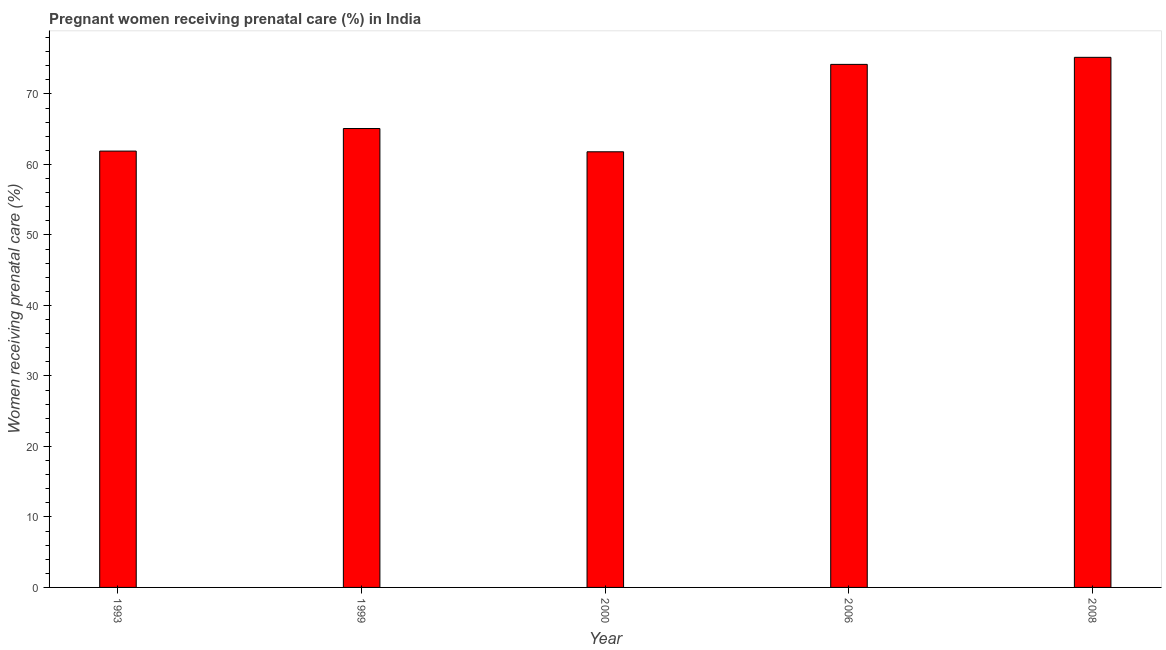Does the graph contain any zero values?
Your response must be concise. No. Does the graph contain grids?
Offer a very short reply. No. What is the title of the graph?
Offer a very short reply. Pregnant women receiving prenatal care (%) in India. What is the label or title of the Y-axis?
Your answer should be very brief. Women receiving prenatal care (%). What is the percentage of pregnant women receiving prenatal care in 1993?
Give a very brief answer. 61.9. Across all years, what is the maximum percentage of pregnant women receiving prenatal care?
Your answer should be very brief. 75.2. Across all years, what is the minimum percentage of pregnant women receiving prenatal care?
Keep it short and to the point. 61.8. In which year was the percentage of pregnant women receiving prenatal care maximum?
Your response must be concise. 2008. In which year was the percentage of pregnant women receiving prenatal care minimum?
Provide a succinct answer. 2000. What is the sum of the percentage of pregnant women receiving prenatal care?
Give a very brief answer. 338.2. What is the average percentage of pregnant women receiving prenatal care per year?
Ensure brevity in your answer.  67.64. What is the median percentage of pregnant women receiving prenatal care?
Your answer should be compact. 65.1. Do a majority of the years between 1993 and 2000 (inclusive) have percentage of pregnant women receiving prenatal care greater than 28 %?
Give a very brief answer. Yes. What is the ratio of the percentage of pregnant women receiving prenatal care in 1999 to that in 2000?
Your response must be concise. 1.05. Is the difference between the percentage of pregnant women receiving prenatal care in 1993 and 2008 greater than the difference between any two years?
Ensure brevity in your answer.  No. What is the difference between the highest and the second highest percentage of pregnant women receiving prenatal care?
Make the answer very short. 1. Is the sum of the percentage of pregnant women receiving prenatal care in 1999 and 2000 greater than the maximum percentage of pregnant women receiving prenatal care across all years?
Offer a very short reply. Yes. What is the difference between the highest and the lowest percentage of pregnant women receiving prenatal care?
Offer a terse response. 13.4. In how many years, is the percentage of pregnant women receiving prenatal care greater than the average percentage of pregnant women receiving prenatal care taken over all years?
Offer a terse response. 2. How many bars are there?
Your answer should be very brief. 5. Are all the bars in the graph horizontal?
Your answer should be compact. No. How many years are there in the graph?
Your answer should be compact. 5. What is the difference between two consecutive major ticks on the Y-axis?
Keep it short and to the point. 10. Are the values on the major ticks of Y-axis written in scientific E-notation?
Your response must be concise. No. What is the Women receiving prenatal care (%) in 1993?
Your answer should be compact. 61.9. What is the Women receiving prenatal care (%) in 1999?
Offer a very short reply. 65.1. What is the Women receiving prenatal care (%) in 2000?
Your answer should be compact. 61.8. What is the Women receiving prenatal care (%) in 2006?
Your answer should be compact. 74.2. What is the Women receiving prenatal care (%) of 2008?
Keep it short and to the point. 75.2. What is the difference between the Women receiving prenatal care (%) in 1993 and 1999?
Offer a very short reply. -3.2. What is the difference between the Women receiving prenatal care (%) in 1993 and 2008?
Offer a terse response. -13.3. What is the difference between the Women receiving prenatal care (%) in 1999 and 2000?
Make the answer very short. 3.3. What is the difference between the Women receiving prenatal care (%) in 1999 and 2006?
Ensure brevity in your answer.  -9.1. What is the difference between the Women receiving prenatal care (%) in 1999 and 2008?
Keep it short and to the point. -10.1. What is the difference between the Women receiving prenatal care (%) in 2000 and 2006?
Provide a short and direct response. -12.4. What is the difference between the Women receiving prenatal care (%) in 2000 and 2008?
Provide a succinct answer. -13.4. What is the difference between the Women receiving prenatal care (%) in 2006 and 2008?
Your response must be concise. -1. What is the ratio of the Women receiving prenatal care (%) in 1993 to that in 1999?
Provide a short and direct response. 0.95. What is the ratio of the Women receiving prenatal care (%) in 1993 to that in 2006?
Your answer should be compact. 0.83. What is the ratio of the Women receiving prenatal care (%) in 1993 to that in 2008?
Make the answer very short. 0.82. What is the ratio of the Women receiving prenatal care (%) in 1999 to that in 2000?
Ensure brevity in your answer.  1.05. What is the ratio of the Women receiving prenatal care (%) in 1999 to that in 2006?
Provide a short and direct response. 0.88. What is the ratio of the Women receiving prenatal care (%) in 1999 to that in 2008?
Provide a short and direct response. 0.87. What is the ratio of the Women receiving prenatal care (%) in 2000 to that in 2006?
Keep it short and to the point. 0.83. What is the ratio of the Women receiving prenatal care (%) in 2000 to that in 2008?
Give a very brief answer. 0.82. What is the ratio of the Women receiving prenatal care (%) in 2006 to that in 2008?
Make the answer very short. 0.99. 